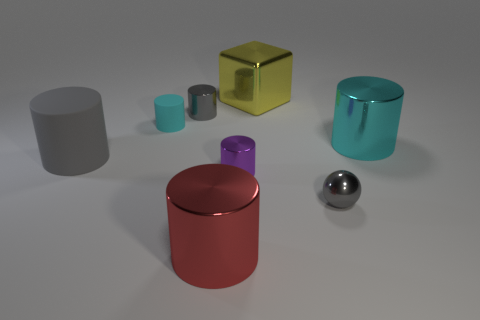There is another metal cylinder that is the same size as the gray metal cylinder; what is its color?
Your answer should be very brief. Purple. There is a cyan cylinder that is left of the small thing that is behind the small rubber object; how big is it?
Your response must be concise. Small. What is the size of the matte object that is the same color as the small sphere?
Make the answer very short. Large. How many other things are there of the same size as the yellow metal cube?
Offer a very short reply. 3. How many large rubber balls are there?
Make the answer very short. 0. Is the size of the red cylinder the same as the yellow thing?
Provide a short and direct response. Yes. How many other things are there of the same shape as the tiny cyan thing?
Keep it short and to the point. 5. There is a tiny gray object on the right side of the metal cylinder that is in front of the purple shiny object; what is its material?
Give a very brief answer. Metal. Are there any cyan metallic objects on the right side of the tiny shiny ball?
Provide a succinct answer. Yes. Does the purple metallic thing have the same size as the rubber cylinder that is in front of the big cyan thing?
Provide a succinct answer. No. 